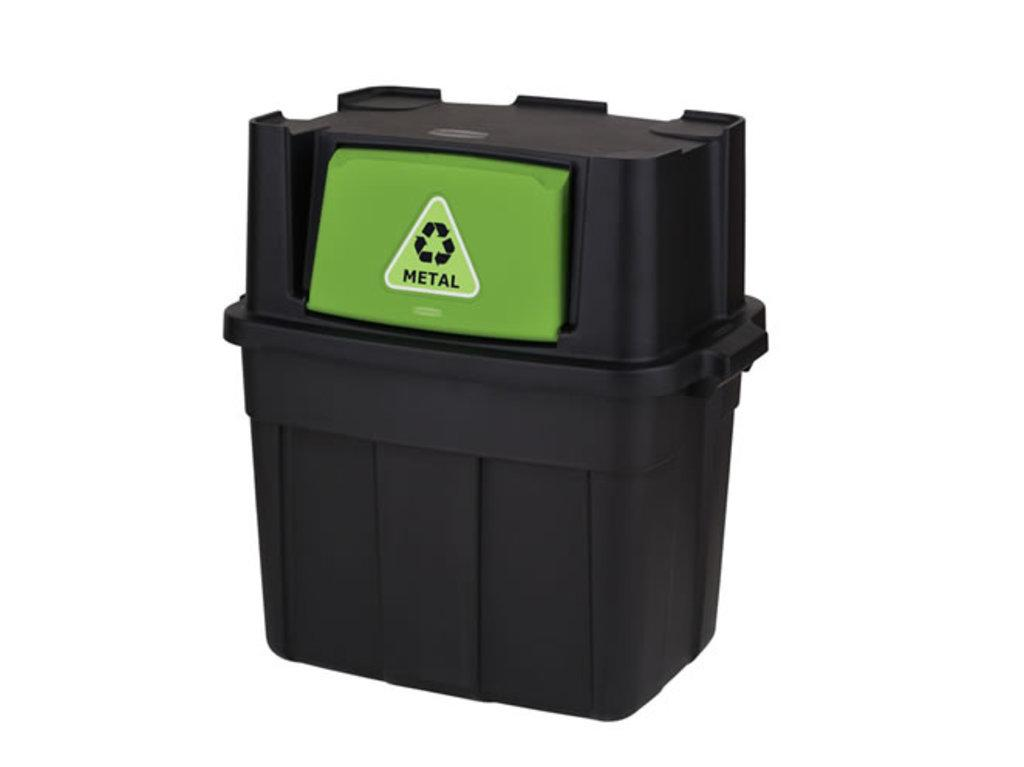<image>
Write a terse but informative summary of the picture. A garbage can-like object with a green lid that reads METAL. 